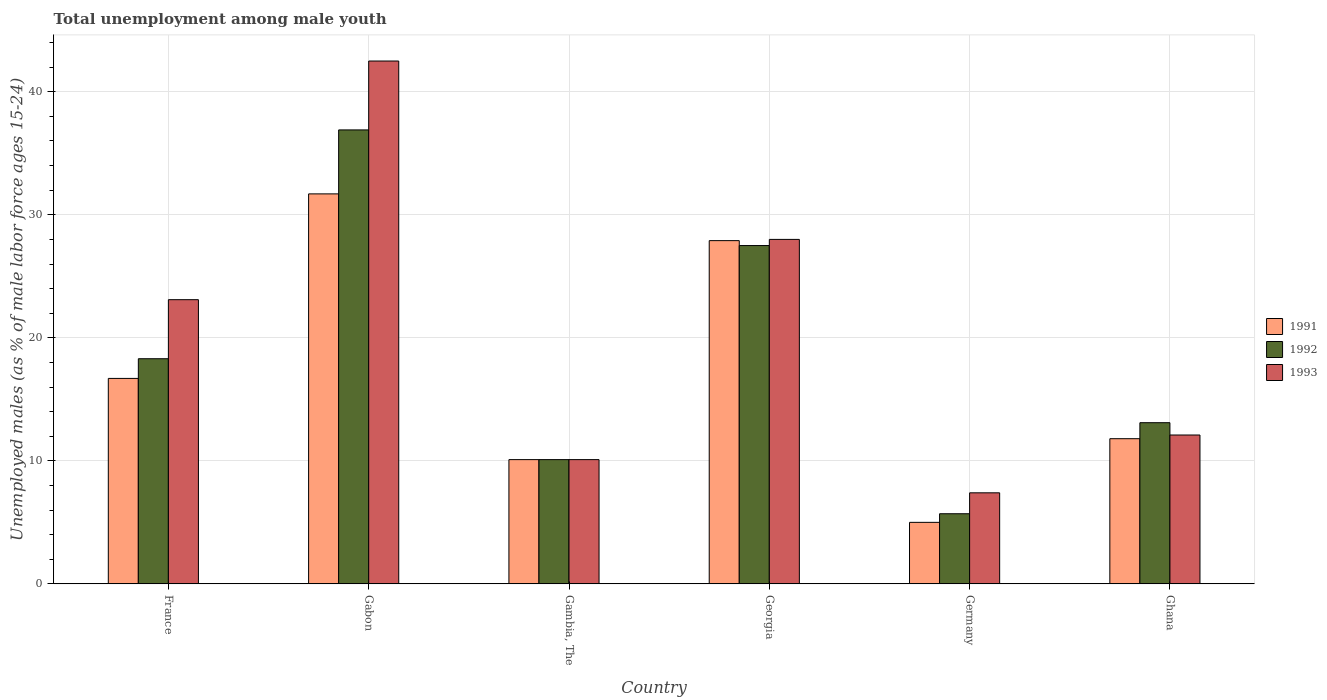How many bars are there on the 5th tick from the left?
Your response must be concise. 3. What is the label of the 5th group of bars from the left?
Make the answer very short. Germany. In how many cases, is the number of bars for a given country not equal to the number of legend labels?
Make the answer very short. 0. What is the percentage of unemployed males in in 1991 in Gambia, The?
Provide a short and direct response. 10.1. Across all countries, what is the maximum percentage of unemployed males in in 1993?
Provide a succinct answer. 42.5. Across all countries, what is the minimum percentage of unemployed males in in 1993?
Provide a short and direct response. 7.4. In which country was the percentage of unemployed males in in 1993 maximum?
Keep it short and to the point. Gabon. In which country was the percentage of unemployed males in in 1991 minimum?
Offer a terse response. Germany. What is the total percentage of unemployed males in in 1992 in the graph?
Ensure brevity in your answer.  111.6. What is the difference between the percentage of unemployed males in in 1991 in Germany and the percentage of unemployed males in in 1993 in Ghana?
Provide a succinct answer. -7.1. What is the average percentage of unemployed males in in 1993 per country?
Offer a terse response. 20.53. What is the ratio of the percentage of unemployed males in in 1991 in Georgia to that in Ghana?
Provide a succinct answer. 2.36. Is the percentage of unemployed males in in 1992 in France less than that in Germany?
Provide a short and direct response. No. Is the difference between the percentage of unemployed males in in 1993 in Gabon and Germany greater than the difference between the percentage of unemployed males in in 1992 in Gabon and Germany?
Offer a terse response. Yes. What is the difference between the highest and the second highest percentage of unemployed males in in 1991?
Provide a succinct answer. -11.2. What is the difference between the highest and the lowest percentage of unemployed males in in 1991?
Provide a succinct answer. 26.7. What does the 3rd bar from the left in Germany represents?
Provide a succinct answer. 1993. What does the 1st bar from the right in France represents?
Provide a succinct answer. 1993. How many bars are there?
Your answer should be compact. 18. Are all the bars in the graph horizontal?
Give a very brief answer. No. Are the values on the major ticks of Y-axis written in scientific E-notation?
Provide a short and direct response. No. Does the graph contain any zero values?
Your answer should be compact. No. What is the title of the graph?
Your answer should be compact. Total unemployment among male youth. Does "1983" appear as one of the legend labels in the graph?
Make the answer very short. No. What is the label or title of the Y-axis?
Provide a short and direct response. Unemployed males (as % of male labor force ages 15-24). What is the Unemployed males (as % of male labor force ages 15-24) in 1991 in France?
Your response must be concise. 16.7. What is the Unemployed males (as % of male labor force ages 15-24) of 1992 in France?
Make the answer very short. 18.3. What is the Unemployed males (as % of male labor force ages 15-24) of 1993 in France?
Make the answer very short. 23.1. What is the Unemployed males (as % of male labor force ages 15-24) in 1991 in Gabon?
Provide a short and direct response. 31.7. What is the Unemployed males (as % of male labor force ages 15-24) of 1992 in Gabon?
Offer a terse response. 36.9. What is the Unemployed males (as % of male labor force ages 15-24) in 1993 in Gabon?
Your response must be concise. 42.5. What is the Unemployed males (as % of male labor force ages 15-24) in 1991 in Gambia, The?
Offer a terse response. 10.1. What is the Unemployed males (as % of male labor force ages 15-24) in 1992 in Gambia, The?
Give a very brief answer. 10.1. What is the Unemployed males (as % of male labor force ages 15-24) in 1993 in Gambia, The?
Offer a very short reply. 10.1. What is the Unemployed males (as % of male labor force ages 15-24) in 1991 in Georgia?
Offer a terse response. 27.9. What is the Unemployed males (as % of male labor force ages 15-24) of 1992 in Georgia?
Provide a short and direct response. 27.5. What is the Unemployed males (as % of male labor force ages 15-24) in 1993 in Georgia?
Your answer should be compact. 28. What is the Unemployed males (as % of male labor force ages 15-24) of 1991 in Germany?
Keep it short and to the point. 5. What is the Unemployed males (as % of male labor force ages 15-24) in 1992 in Germany?
Your response must be concise. 5.7. What is the Unemployed males (as % of male labor force ages 15-24) in 1993 in Germany?
Keep it short and to the point. 7.4. What is the Unemployed males (as % of male labor force ages 15-24) in 1991 in Ghana?
Your answer should be compact. 11.8. What is the Unemployed males (as % of male labor force ages 15-24) of 1992 in Ghana?
Keep it short and to the point. 13.1. What is the Unemployed males (as % of male labor force ages 15-24) in 1993 in Ghana?
Your response must be concise. 12.1. Across all countries, what is the maximum Unemployed males (as % of male labor force ages 15-24) of 1991?
Ensure brevity in your answer.  31.7. Across all countries, what is the maximum Unemployed males (as % of male labor force ages 15-24) in 1992?
Your answer should be compact. 36.9. Across all countries, what is the maximum Unemployed males (as % of male labor force ages 15-24) in 1993?
Your answer should be compact. 42.5. Across all countries, what is the minimum Unemployed males (as % of male labor force ages 15-24) in 1991?
Provide a succinct answer. 5. Across all countries, what is the minimum Unemployed males (as % of male labor force ages 15-24) in 1992?
Your answer should be very brief. 5.7. Across all countries, what is the minimum Unemployed males (as % of male labor force ages 15-24) in 1993?
Offer a very short reply. 7.4. What is the total Unemployed males (as % of male labor force ages 15-24) of 1991 in the graph?
Provide a short and direct response. 103.2. What is the total Unemployed males (as % of male labor force ages 15-24) of 1992 in the graph?
Offer a very short reply. 111.6. What is the total Unemployed males (as % of male labor force ages 15-24) in 1993 in the graph?
Your response must be concise. 123.2. What is the difference between the Unemployed males (as % of male labor force ages 15-24) in 1992 in France and that in Gabon?
Make the answer very short. -18.6. What is the difference between the Unemployed males (as % of male labor force ages 15-24) in 1993 in France and that in Gabon?
Make the answer very short. -19.4. What is the difference between the Unemployed males (as % of male labor force ages 15-24) of 1991 in France and that in Gambia, The?
Your answer should be very brief. 6.6. What is the difference between the Unemployed males (as % of male labor force ages 15-24) in 1992 in France and that in Gambia, The?
Ensure brevity in your answer.  8.2. What is the difference between the Unemployed males (as % of male labor force ages 15-24) in 1993 in France and that in Gambia, The?
Ensure brevity in your answer.  13. What is the difference between the Unemployed males (as % of male labor force ages 15-24) of 1991 in France and that in Georgia?
Make the answer very short. -11.2. What is the difference between the Unemployed males (as % of male labor force ages 15-24) of 1992 in France and that in Georgia?
Ensure brevity in your answer.  -9.2. What is the difference between the Unemployed males (as % of male labor force ages 15-24) of 1993 in France and that in Georgia?
Make the answer very short. -4.9. What is the difference between the Unemployed males (as % of male labor force ages 15-24) in 1991 in France and that in Germany?
Your response must be concise. 11.7. What is the difference between the Unemployed males (as % of male labor force ages 15-24) in 1991 in France and that in Ghana?
Provide a succinct answer. 4.9. What is the difference between the Unemployed males (as % of male labor force ages 15-24) in 1992 in France and that in Ghana?
Offer a terse response. 5.2. What is the difference between the Unemployed males (as % of male labor force ages 15-24) of 1991 in Gabon and that in Gambia, The?
Provide a short and direct response. 21.6. What is the difference between the Unemployed males (as % of male labor force ages 15-24) in 1992 in Gabon and that in Gambia, The?
Keep it short and to the point. 26.8. What is the difference between the Unemployed males (as % of male labor force ages 15-24) of 1993 in Gabon and that in Gambia, The?
Offer a terse response. 32.4. What is the difference between the Unemployed males (as % of male labor force ages 15-24) of 1991 in Gabon and that in Germany?
Ensure brevity in your answer.  26.7. What is the difference between the Unemployed males (as % of male labor force ages 15-24) of 1992 in Gabon and that in Germany?
Your answer should be compact. 31.2. What is the difference between the Unemployed males (as % of male labor force ages 15-24) of 1993 in Gabon and that in Germany?
Your response must be concise. 35.1. What is the difference between the Unemployed males (as % of male labor force ages 15-24) in 1991 in Gabon and that in Ghana?
Give a very brief answer. 19.9. What is the difference between the Unemployed males (as % of male labor force ages 15-24) of 1992 in Gabon and that in Ghana?
Make the answer very short. 23.8. What is the difference between the Unemployed males (as % of male labor force ages 15-24) of 1993 in Gabon and that in Ghana?
Keep it short and to the point. 30.4. What is the difference between the Unemployed males (as % of male labor force ages 15-24) of 1991 in Gambia, The and that in Georgia?
Provide a short and direct response. -17.8. What is the difference between the Unemployed males (as % of male labor force ages 15-24) of 1992 in Gambia, The and that in Georgia?
Provide a succinct answer. -17.4. What is the difference between the Unemployed males (as % of male labor force ages 15-24) of 1993 in Gambia, The and that in Georgia?
Your answer should be compact. -17.9. What is the difference between the Unemployed males (as % of male labor force ages 15-24) in 1991 in Gambia, The and that in Germany?
Your answer should be very brief. 5.1. What is the difference between the Unemployed males (as % of male labor force ages 15-24) in 1992 in Gambia, The and that in Germany?
Provide a short and direct response. 4.4. What is the difference between the Unemployed males (as % of male labor force ages 15-24) in 1991 in Gambia, The and that in Ghana?
Keep it short and to the point. -1.7. What is the difference between the Unemployed males (as % of male labor force ages 15-24) in 1993 in Gambia, The and that in Ghana?
Offer a terse response. -2. What is the difference between the Unemployed males (as % of male labor force ages 15-24) of 1991 in Georgia and that in Germany?
Offer a very short reply. 22.9. What is the difference between the Unemployed males (as % of male labor force ages 15-24) in 1992 in Georgia and that in Germany?
Your answer should be compact. 21.8. What is the difference between the Unemployed males (as % of male labor force ages 15-24) in 1993 in Georgia and that in Germany?
Provide a short and direct response. 20.6. What is the difference between the Unemployed males (as % of male labor force ages 15-24) in 1992 in Georgia and that in Ghana?
Your response must be concise. 14.4. What is the difference between the Unemployed males (as % of male labor force ages 15-24) in 1992 in Germany and that in Ghana?
Give a very brief answer. -7.4. What is the difference between the Unemployed males (as % of male labor force ages 15-24) in 1991 in France and the Unemployed males (as % of male labor force ages 15-24) in 1992 in Gabon?
Keep it short and to the point. -20.2. What is the difference between the Unemployed males (as % of male labor force ages 15-24) in 1991 in France and the Unemployed males (as % of male labor force ages 15-24) in 1993 in Gabon?
Offer a terse response. -25.8. What is the difference between the Unemployed males (as % of male labor force ages 15-24) in 1992 in France and the Unemployed males (as % of male labor force ages 15-24) in 1993 in Gabon?
Offer a terse response. -24.2. What is the difference between the Unemployed males (as % of male labor force ages 15-24) of 1991 in France and the Unemployed males (as % of male labor force ages 15-24) of 1992 in Gambia, The?
Keep it short and to the point. 6.6. What is the difference between the Unemployed males (as % of male labor force ages 15-24) of 1991 in France and the Unemployed males (as % of male labor force ages 15-24) of 1993 in Gambia, The?
Make the answer very short. 6.6. What is the difference between the Unemployed males (as % of male labor force ages 15-24) in 1991 in France and the Unemployed males (as % of male labor force ages 15-24) in 1992 in Georgia?
Provide a short and direct response. -10.8. What is the difference between the Unemployed males (as % of male labor force ages 15-24) of 1991 in France and the Unemployed males (as % of male labor force ages 15-24) of 1992 in Germany?
Keep it short and to the point. 11. What is the difference between the Unemployed males (as % of male labor force ages 15-24) of 1991 in France and the Unemployed males (as % of male labor force ages 15-24) of 1993 in Germany?
Provide a short and direct response. 9.3. What is the difference between the Unemployed males (as % of male labor force ages 15-24) of 1992 in France and the Unemployed males (as % of male labor force ages 15-24) of 1993 in Germany?
Give a very brief answer. 10.9. What is the difference between the Unemployed males (as % of male labor force ages 15-24) of 1991 in Gabon and the Unemployed males (as % of male labor force ages 15-24) of 1992 in Gambia, The?
Your answer should be compact. 21.6. What is the difference between the Unemployed males (as % of male labor force ages 15-24) of 1991 in Gabon and the Unemployed males (as % of male labor force ages 15-24) of 1993 in Gambia, The?
Provide a short and direct response. 21.6. What is the difference between the Unemployed males (as % of male labor force ages 15-24) in 1992 in Gabon and the Unemployed males (as % of male labor force ages 15-24) in 1993 in Gambia, The?
Your answer should be compact. 26.8. What is the difference between the Unemployed males (as % of male labor force ages 15-24) in 1991 in Gabon and the Unemployed males (as % of male labor force ages 15-24) in 1993 in Germany?
Provide a succinct answer. 24.3. What is the difference between the Unemployed males (as % of male labor force ages 15-24) in 1992 in Gabon and the Unemployed males (as % of male labor force ages 15-24) in 1993 in Germany?
Keep it short and to the point. 29.5. What is the difference between the Unemployed males (as % of male labor force ages 15-24) of 1991 in Gabon and the Unemployed males (as % of male labor force ages 15-24) of 1993 in Ghana?
Your response must be concise. 19.6. What is the difference between the Unemployed males (as % of male labor force ages 15-24) of 1992 in Gabon and the Unemployed males (as % of male labor force ages 15-24) of 1993 in Ghana?
Provide a succinct answer. 24.8. What is the difference between the Unemployed males (as % of male labor force ages 15-24) in 1991 in Gambia, The and the Unemployed males (as % of male labor force ages 15-24) in 1992 in Georgia?
Ensure brevity in your answer.  -17.4. What is the difference between the Unemployed males (as % of male labor force ages 15-24) in 1991 in Gambia, The and the Unemployed males (as % of male labor force ages 15-24) in 1993 in Georgia?
Your answer should be very brief. -17.9. What is the difference between the Unemployed males (as % of male labor force ages 15-24) of 1992 in Gambia, The and the Unemployed males (as % of male labor force ages 15-24) of 1993 in Georgia?
Provide a succinct answer. -17.9. What is the difference between the Unemployed males (as % of male labor force ages 15-24) in 1991 in Gambia, The and the Unemployed males (as % of male labor force ages 15-24) in 1992 in Germany?
Ensure brevity in your answer.  4.4. What is the difference between the Unemployed males (as % of male labor force ages 15-24) of 1992 in Gambia, The and the Unemployed males (as % of male labor force ages 15-24) of 1993 in Germany?
Give a very brief answer. 2.7. What is the difference between the Unemployed males (as % of male labor force ages 15-24) in 1992 in Gambia, The and the Unemployed males (as % of male labor force ages 15-24) in 1993 in Ghana?
Keep it short and to the point. -2. What is the difference between the Unemployed males (as % of male labor force ages 15-24) in 1991 in Georgia and the Unemployed males (as % of male labor force ages 15-24) in 1993 in Germany?
Keep it short and to the point. 20.5. What is the difference between the Unemployed males (as % of male labor force ages 15-24) in 1992 in Georgia and the Unemployed males (as % of male labor force ages 15-24) in 1993 in Germany?
Provide a short and direct response. 20.1. What is the difference between the Unemployed males (as % of male labor force ages 15-24) of 1991 in Georgia and the Unemployed males (as % of male labor force ages 15-24) of 1993 in Ghana?
Ensure brevity in your answer.  15.8. What is the difference between the Unemployed males (as % of male labor force ages 15-24) of 1992 in Georgia and the Unemployed males (as % of male labor force ages 15-24) of 1993 in Ghana?
Your answer should be very brief. 15.4. What is the difference between the Unemployed males (as % of male labor force ages 15-24) of 1991 in Germany and the Unemployed males (as % of male labor force ages 15-24) of 1993 in Ghana?
Offer a very short reply. -7.1. What is the average Unemployed males (as % of male labor force ages 15-24) in 1993 per country?
Your answer should be compact. 20.53. What is the difference between the Unemployed males (as % of male labor force ages 15-24) of 1991 and Unemployed males (as % of male labor force ages 15-24) of 1992 in Gabon?
Ensure brevity in your answer.  -5.2. What is the difference between the Unemployed males (as % of male labor force ages 15-24) of 1991 and Unemployed males (as % of male labor force ages 15-24) of 1993 in Gabon?
Your answer should be very brief. -10.8. What is the difference between the Unemployed males (as % of male labor force ages 15-24) in 1991 and Unemployed males (as % of male labor force ages 15-24) in 1993 in Gambia, The?
Your response must be concise. 0. What is the difference between the Unemployed males (as % of male labor force ages 15-24) in 1992 and Unemployed males (as % of male labor force ages 15-24) in 1993 in Gambia, The?
Your response must be concise. 0. What is the difference between the Unemployed males (as % of male labor force ages 15-24) in 1991 and Unemployed males (as % of male labor force ages 15-24) in 1992 in Georgia?
Your response must be concise. 0.4. What is the difference between the Unemployed males (as % of male labor force ages 15-24) of 1992 and Unemployed males (as % of male labor force ages 15-24) of 1993 in Georgia?
Your answer should be very brief. -0.5. What is the difference between the Unemployed males (as % of male labor force ages 15-24) of 1991 and Unemployed males (as % of male labor force ages 15-24) of 1992 in Ghana?
Make the answer very short. -1.3. What is the difference between the Unemployed males (as % of male labor force ages 15-24) in 1992 and Unemployed males (as % of male labor force ages 15-24) in 1993 in Ghana?
Ensure brevity in your answer.  1. What is the ratio of the Unemployed males (as % of male labor force ages 15-24) of 1991 in France to that in Gabon?
Provide a short and direct response. 0.53. What is the ratio of the Unemployed males (as % of male labor force ages 15-24) of 1992 in France to that in Gabon?
Your answer should be compact. 0.5. What is the ratio of the Unemployed males (as % of male labor force ages 15-24) of 1993 in France to that in Gabon?
Provide a short and direct response. 0.54. What is the ratio of the Unemployed males (as % of male labor force ages 15-24) in 1991 in France to that in Gambia, The?
Your answer should be very brief. 1.65. What is the ratio of the Unemployed males (as % of male labor force ages 15-24) of 1992 in France to that in Gambia, The?
Ensure brevity in your answer.  1.81. What is the ratio of the Unemployed males (as % of male labor force ages 15-24) in 1993 in France to that in Gambia, The?
Your answer should be compact. 2.29. What is the ratio of the Unemployed males (as % of male labor force ages 15-24) of 1991 in France to that in Georgia?
Make the answer very short. 0.6. What is the ratio of the Unemployed males (as % of male labor force ages 15-24) in 1992 in France to that in Georgia?
Ensure brevity in your answer.  0.67. What is the ratio of the Unemployed males (as % of male labor force ages 15-24) of 1993 in France to that in Georgia?
Provide a short and direct response. 0.82. What is the ratio of the Unemployed males (as % of male labor force ages 15-24) of 1991 in France to that in Germany?
Provide a short and direct response. 3.34. What is the ratio of the Unemployed males (as % of male labor force ages 15-24) of 1992 in France to that in Germany?
Offer a very short reply. 3.21. What is the ratio of the Unemployed males (as % of male labor force ages 15-24) in 1993 in France to that in Germany?
Provide a short and direct response. 3.12. What is the ratio of the Unemployed males (as % of male labor force ages 15-24) in 1991 in France to that in Ghana?
Your response must be concise. 1.42. What is the ratio of the Unemployed males (as % of male labor force ages 15-24) of 1992 in France to that in Ghana?
Offer a terse response. 1.4. What is the ratio of the Unemployed males (as % of male labor force ages 15-24) in 1993 in France to that in Ghana?
Offer a very short reply. 1.91. What is the ratio of the Unemployed males (as % of male labor force ages 15-24) of 1991 in Gabon to that in Gambia, The?
Make the answer very short. 3.14. What is the ratio of the Unemployed males (as % of male labor force ages 15-24) of 1992 in Gabon to that in Gambia, The?
Offer a very short reply. 3.65. What is the ratio of the Unemployed males (as % of male labor force ages 15-24) in 1993 in Gabon to that in Gambia, The?
Make the answer very short. 4.21. What is the ratio of the Unemployed males (as % of male labor force ages 15-24) of 1991 in Gabon to that in Georgia?
Provide a succinct answer. 1.14. What is the ratio of the Unemployed males (as % of male labor force ages 15-24) of 1992 in Gabon to that in Georgia?
Your answer should be compact. 1.34. What is the ratio of the Unemployed males (as % of male labor force ages 15-24) of 1993 in Gabon to that in Georgia?
Offer a very short reply. 1.52. What is the ratio of the Unemployed males (as % of male labor force ages 15-24) in 1991 in Gabon to that in Germany?
Make the answer very short. 6.34. What is the ratio of the Unemployed males (as % of male labor force ages 15-24) of 1992 in Gabon to that in Germany?
Your answer should be very brief. 6.47. What is the ratio of the Unemployed males (as % of male labor force ages 15-24) of 1993 in Gabon to that in Germany?
Your answer should be very brief. 5.74. What is the ratio of the Unemployed males (as % of male labor force ages 15-24) of 1991 in Gabon to that in Ghana?
Your response must be concise. 2.69. What is the ratio of the Unemployed males (as % of male labor force ages 15-24) of 1992 in Gabon to that in Ghana?
Offer a very short reply. 2.82. What is the ratio of the Unemployed males (as % of male labor force ages 15-24) in 1993 in Gabon to that in Ghana?
Make the answer very short. 3.51. What is the ratio of the Unemployed males (as % of male labor force ages 15-24) of 1991 in Gambia, The to that in Georgia?
Keep it short and to the point. 0.36. What is the ratio of the Unemployed males (as % of male labor force ages 15-24) in 1992 in Gambia, The to that in Georgia?
Ensure brevity in your answer.  0.37. What is the ratio of the Unemployed males (as % of male labor force ages 15-24) in 1993 in Gambia, The to that in Georgia?
Give a very brief answer. 0.36. What is the ratio of the Unemployed males (as % of male labor force ages 15-24) in 1991 in Gambia, The to that in Germany?
Your answer should be compact. 2.02. What is the ratio of the Unemployed males (as % of male labor force ages 15-24) of 1992 in Gambia, The to that in Germany?
Ensure brevity in your answer.  1.77. What is the ratio of the Unemployed males (as % of male labor force ages 15-24) in 1993 in Gambia, The to that in Germany?
Ensure brevity in your answer.  1.36. What is the ratio of the Unemployed males (as % of male labor force ages 15-24) in 1991 in Gambia, The to that in Ghana?
Keep it short and to the point. 0.86. What is the ratio of the Unemployed males (as % of male labor force ages 15-24) of 1992 in Gambia, The to that in Ghana?
Provide a short and direct response. 0.77. What is the ratio of the Unemployed males (as % of male labor force ages 15-24) in 1993 in Gambia, The to that in Ghana?
Offer a terse response. 0.83. What is the ratio of the Unemployed males (as % of male labor force ages 15-24) in 1991 in Georgia to that in Germany?
Give a very brief answer. 5.58. What is the ratio of the Unemployed males (as % of male labor force ages 15-24) in 1992 in Georgia to that in Germany?
Your response must be concise. 4.82. What is the ratio of the Unemployed males (as % of male labor force ages 15-24) in 1993 in Georgia to that in Germany?
Offer a terse response. 3.78. What is the ratio of the Unemployed males (as % of male labor force ages 15-24) of 1991 in Georgia to that in Ghana?
Your answer should be compact. 2.36. What is the ratio of the Unemployed males (as % of male labor force ages 15-24) of 1992 in Georgia to that in Ghana?
Provide a succinct answer. 2.1. What is the ratio of the Unemployed males (as % of male labor force ages 15-24) of 1993 in Georgia to that in Ghana?
Ensure brevity in your answer.  2.31. What is the ratio of the Unemployed males (as % of male labor force ages 15-24) in 1991 in Germany to that in Ghana?
Your answer should be compact. 0.42. What is the ratio of the Unemployed males (as % of male labor force ages 15-24) in 1992 in Germany to that in Ghana?
Your answer should be very brief. 0.44. What is the ratio of the Unemployed males (as % of male labor force ages 15-24) in 1993 in Germany to that in Ghana?
Give a very brief answer. 0.61. What is the difference between the highest and the second highest Unemployed males (as % of male labor force ages 15-24) of 1991?
Provide a short and direct response. 3.8. What is the difference between the highest and the lowest Unemployed males (as % of male labor force ages 15-24) in 1991?
Make the answer very short. 26.7. What is the difference between the highest and the lowest Unemployed males (as % of male labor force ages 15-24) in 1992?
Your answer should be compact. 31.2. What is the difference between the highest and the lowest Unemployed males (as % of male labor force ages 15-24) in 1993?
Keep it short and to the point. 35.1. 